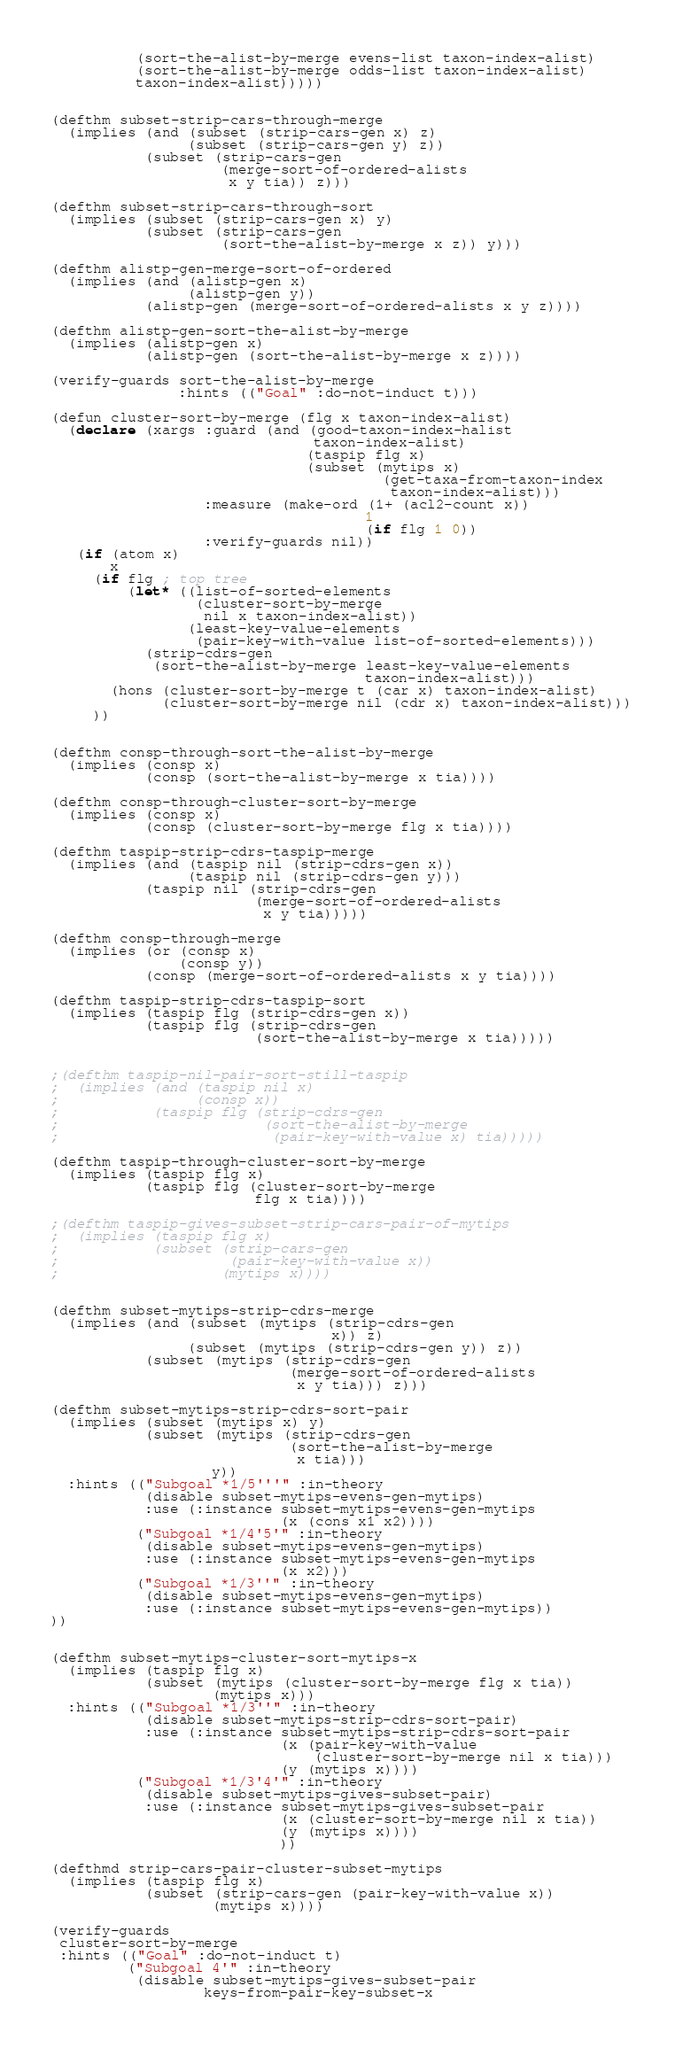Convert code to text. <code><loc_0><loc_0><loc_500><loc_500><_Lisp_>          (sort-the-alist-by-merge evens-list taxon-index-alist)
          (sort-the-alist-by-merge odds-list taxon-index-alist)
          taxon-index-alist)))))


(defthm subset-strip-cars-through-merge
  (implies (and (subset (strip-cars-gen x) z)
                (subset (strip-cars-gen y) z))
           (subset (strip-cars-gen 
                    (merge-sort-of-ordered-alists
                     x y tia)) z)))

(defthm subset-strip-cars-through-sort
  (implies (subset (strip-cars-gen x) y)
           (subset (strip-cars-gen
                    (sort-the-alist-by-merge x z)) y)))

(defthm alistp-gen-merge-sort-of-ordered
  (implies (and (alistp-gen x)
                (alistp-gen y))
           (alistp-gen (merge-sort-of-ordered-alists x y z))))

(defthm alistp-gen-sort-the-alist-by-merge
  (implies (alistp-gen x)
           (alistp-gen (sort-the-alist-by-merge x z))))

(verify-guards sort-the-alist-by-merge
               :hints (("Goal" :do-not-induct t)))

(defun cluster-sort-by-merge (flg x taxon-index-alist)
  (declare (xargs :guard (and (good-taxon-index-halist
                               taxon-index-alist)
                              (taspip flg x)
                              (subset (mytips x)
                                       (get-taxa-from-taxon-index
                                        taxon-index-alist)))
                  :measure (make-ord (1+ (acl2-count x))
                                     1
                                     (if flg 1 0))
                  :verify-guards nil))
   (if (atom x)
       x
     (if flg ; top tree
         (let* ((list-of-sorted-elements
                 (cluster-sort-by-merge
                  nil x taxon-index-alist))
                (least-key-value-elements 
                 (pair-key-with-value list-of-sorted-elements)))
           (strip-cdrs-gen
            (sort-the-alist-by-merge least-key-value-elements
                                     taxon-index-alist)))
       (hons (cluster-sort-by-merge t (car x) taxon-index-alist)
             (cluster-sort-by-merge nil (cdr x) taxon-index-alist)))
     ))


(defthm consp-through-sort-the-alist-by-merge
  (implies (consp x)
           (consp (sort-the-alist-by-merge x tia))))

(defthm consp-through-cluster-sort-by-merge
  (implies (consp x)
           (consp (cluster-sort-by-merge flg x tia))))

(defthm taspip-strip-cdrs-taspip-merge
  (implies (and (taspip nil (strip-cdrs-gen x))
                (taspip nil (strip-cdrs-gen y)))
           (taspip nil (strip-cdrs-gen 
                        (merge-sort-of-ordered-alists
                         x y tia)))))

(defthm consp-through-merge
  (implies (or (consp x)
               (consp y))
           (consp (merge-sort-of-ordered-alists x y tia))))

(defthm taspip-strip-cdrs-taspip-sort
  (implies (taspip flg (strip-cdrs-gen x))
           (taspip flg (strip-cdrs-gen 
                        (sort-the-alist-by-merge x tia)))))


;(defthm taspip-nil-pair-sort-still-taspip
;  (implies (and (taspip nil x)
;                (consp x))
;           (taspip flg (strip-cdrs-gen
;                        (sort-the-alist-by-merge
;                         (pair-key-with-value x) tia)))))

(defthm taspip-through-cluster-sort-by-merge
  (implies (taspip flg x)
           (taspip flg (cluster-sort-by-merge
                        flg x tia))))

;(defthm taspip-gives-subset-strip-cars-pair-of-mytips
;  (implies (taspip flg x)
;           (subset (strip-cars-gen
;                    (pair-key-with-value x))
;                   (mytips x))))


(defthm subset-mytips-strip-cdrs-merge
  (implies (and (subset (mytips (strip-cdrs-gen
                                 x)) z)
                (subset (mytips (strip-cdrs-gen y)) z))
           (subset (mytips (strip-cdrs-gen
                            (merge-sort-of-ordered-alists
                             x y tia))) z)))

(defthm subset-mytips-strip-cdrs-sort-pair
  (implies (subset (mytips x) y)
           (subset (mytips (strip-cdrs-gen 
                            (sort-the-alist-by-merge
                             x tia)))
                   y))
  :hints (("Subgoal *1/5'''" :in-theory 
           (disable subset-mytips-evens-gen-mytips)
           :use (:instance subset-mytips-evens-gen-mytips
                           (x (cons x1 x2))))
          ("Subgoal *1/4'5'" :in-theory 
           (disable subset-mytips-evens-gen-mytips)
           :use (:instance subset-mytips-evens-gen-mytips
                           (x x2)))
          ("Subgoal *1/3''" :in-theory 
           (disable subset-mytips-evens-gen-mytips)
           :use (:instance subset-mytips-evens-gen-mytips))
))


(defthm subset-mytips-cluster-sort-mytips-x
  (implies (taspip flg x)
           (subset (mytips (cluster-sort-by-merge flg x tia))
                   (mytips x)))
  :hints (("Subgoal *1/3''" :in-theory 
           (disable subset-mytips-strip-cdrs-sort-pair)
           :use (:instance subset-mytips-strip-cdrs-sort-pair
                           (x (pair-key-with-value 
                               (cluster-sort-by-merge nil x tia)))
                           (y (mytips x))))
          ("Subgoal *1/3'4'" :in-theory 
           (disable subset-mytips-gives-subset-pair)
           :use (:instance subset-mytips-gives-subset-pair
                           (x (cluster-sort-by-merge nil x tia))
                           (y (mytips x))))
                           ))

(defthmd strip-cars-pair-cluster-subset-mytips
  (implies (taspip flg x)
           (subset (strip-cars-gen (pair-key-with-value x))
                   (mytips x))))

(verify-guards 
 cluster-sort-by-merge
 :hints (("Goal" :do-not-induct t)
         ("Subgoal 4'" :in-theory 
          (disable subset-mytips-gives-subset-pair
                  keys-from-pair-key-subset-x</code> 